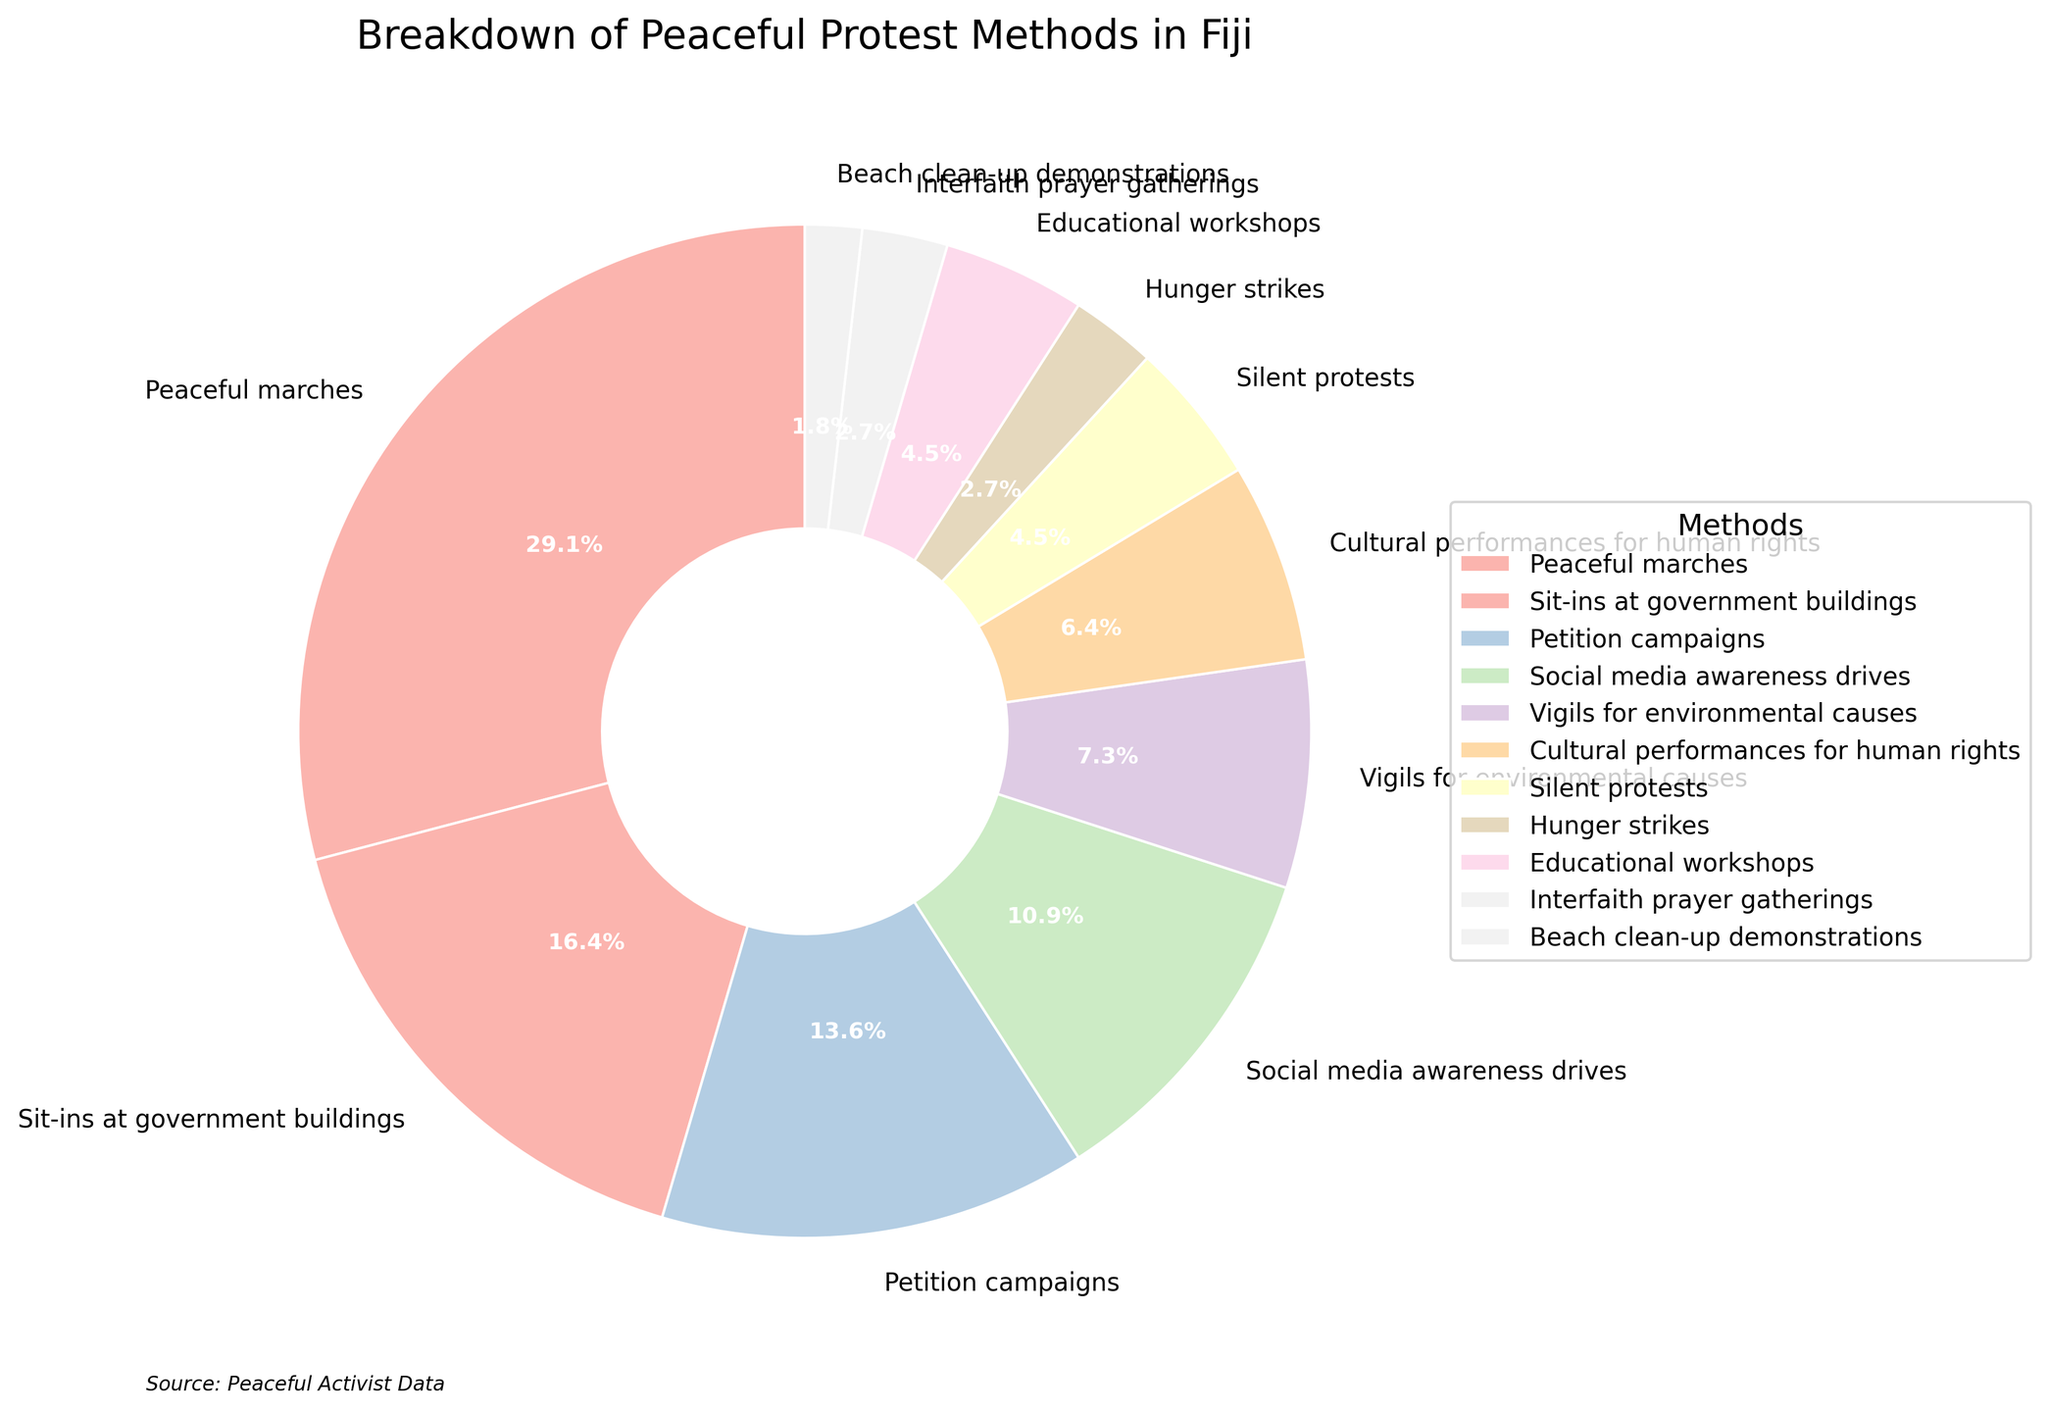What's the most commonly used peaceful protest method? The most commonly used peaceful protest method can be identified by looking for the largest segment in the pie chart. The largest segment represents "Peaceful marches" with 32%.
Answer: Peaceful marches What percentage of protests are sit-ins at government buildings and petition campaigns combined? To find the combined percentage, add the percentages of sit-ins at government buildings (18%) and petition campaigns (15%). The sum is 18% + 15% = 33%.
Answer: 33% Which peaceful protest methods have the same percentage of usage? Looking at the pie chart, "Silent protests" and "Educational workshops" both have the same percentage of usage, each at 5%.
Answer: Silent protests and Educational workshops What is the difference in percentage between social media awareness drives and hunger strikes? To find the difference, subtract the percentage of hunger strikes (3%) from the percentage of social media awareness drives (12%). The difference is 12% - 3% = 9%.
Answer: 9% Which method occupies a larger share of the chart: cultural performances for human rights or vigils for environmental causes? By comparing the segments in the pie chart, "Vigils for environmental causes" is 8%, which is larger than "Cultural performances for human rights" at 7%.
Answer: Vigils for environmental causes How many methods account for less than 5% of the total protests? To count the methods less than 5%, there are "Hunger strikes" (3%), "Interfaith prayer gatherings" (3%), and "Beach clean-up demonstrations" (2%), which make a total of three methods.
Answer: 3 What's the sum of the percentages for the least and the most used methods? The least used method is "Beach clean-up demonstrations" at 2%, and the most used method is "Peaceful marches" at 32%. The sum is 2% + 32% = 34%.
Answer: 34% Which protest method accounts for 12% of the total? Identify the segment labeled with 12% in the pie chart. It corresponds to "Social media awareness drives".
Answer: Social media awareness drives By how much does the percentage of petition campaigns exceed that of educational workshops? Subtract the percentage of educational workshops (5%) from petition campaigns (15%). The difference is 15% - 5% = 10%.
Answer: 10% What fraction of protests consist of either sit-ins at government buildings or cultural performances for human rights? Add the percentages for sit-ins at government buildings (18%) and cultural performances for human rights (7%). The fraction is 18% + 7% = 25%.
Answer: 25% 